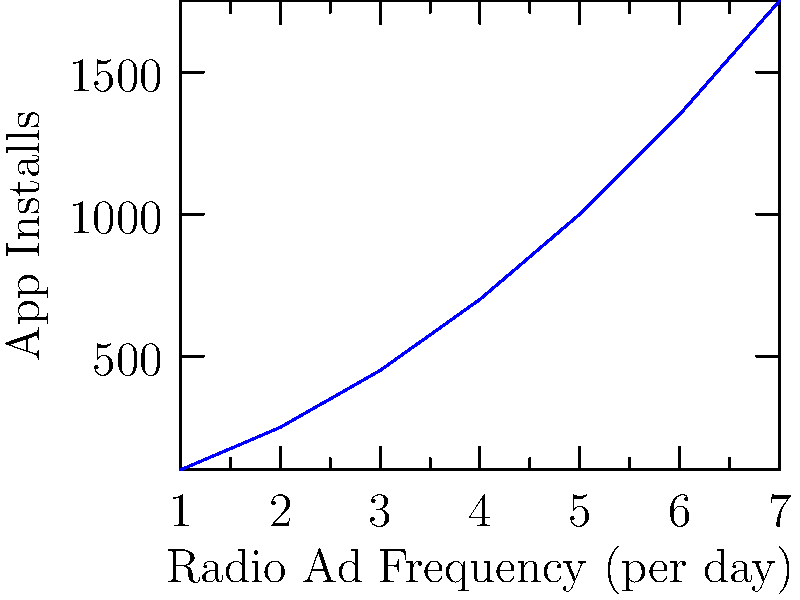The graph shows the relationship between radio ad frequency and app installs for a new tech startup. If the startup increases its radio ad frequency from 3 to 5 times per day, what is the expected increase in daily app installs? To solve this problem, we need to follow these steps:

1. Identify the number of app installs at 3 ads per day:
   At x = 3, y ≈ 450 installs

2. Identify the number of app installs at 5 ads per day:
   At x = 5, y ≈ 1000 installs

3. Calculate the difference:
   $1000 - 450 = 550$

Therefore, by increasing the radio ad frequency from 3 to 5 times per day, the startup can expect an increase of approximately 550 daily app installs.
Answer: 550 installs 